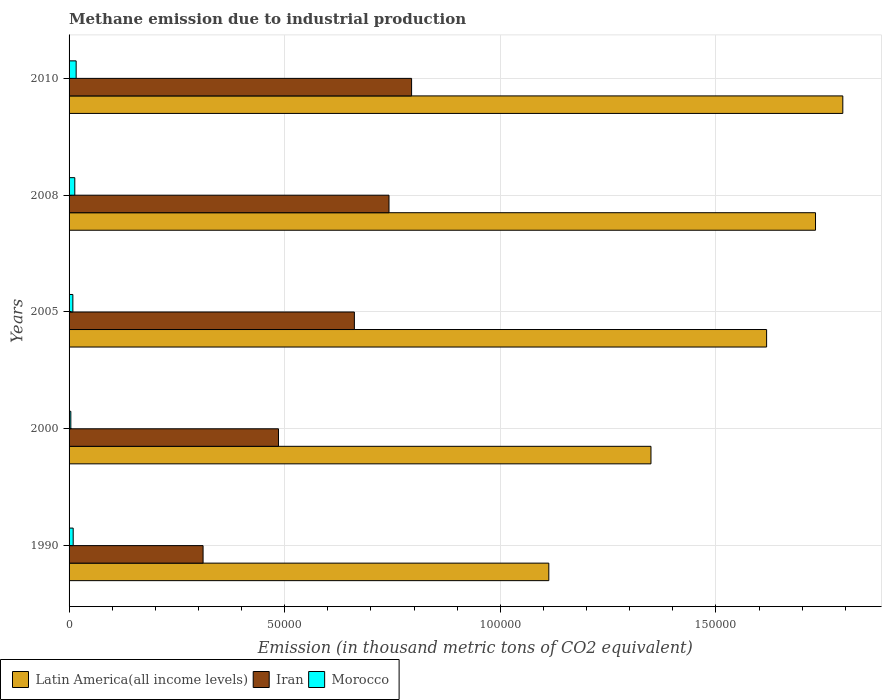How many different coloured bars are there?
Your response must be concise. 3. How many groups of bars are there?
Give a very brief answer. 5. How many bars are there on the 1st tick from the bottom?
Keep it short and to the point. 3. What is the label of the 5th group of bars from the top?
Your response must be concise. 1990. What is the amount of methane emitted in Latin America(all income levels) in 2000?
Make the answer very short. 1.35e+05. Across all years, what is the maximum amount of methane emitted in Latin America(all income levels)?
Your answer should be very brief. 1.79e+05. Across all years, what is the minimum amount of methane emitted in Iran?
Your response must be concise. 3.11e+04. In which year was the amount of methane emitted in Morocco minimum?
Give a very brief answer. 2000. What is the total amount of methane emitted in Latin America(all income levels) in the graph?
Your response must be concise. 7.60e+05. What is the difference between the amount of methane emitted in Iran in 2005 and that in 2008?
Provide a short and direct response. -8028.1. What is the difference between the amount of methane emitted in Morocco in 2005 and the amount of methane emitted in Latin America(all income levels) in 2008?
Make the answer very short. -1.72e+05. What is the average amount of methane emitted in Iran per year?
Ensure brevity in your answer.  5.99e+04. In the year 2010, what is the difference between the amount of methane emitted in Latin America(all income levels) and amount of methane emitted in Morocco?
Your answer should be compact. 1.78e+05. In how many years, is the amount of methane emitted in Latin America(all income levels) greater than 100000 thousand metric tons?
Keep it short and to the point. 5. What is the ratio of the amount of methane emitted in Morocco in 2000 to that in 2008?
Offer a very short reply. 0.31. Is the difference between the amount of methane emitted in Latin America(all income levels) in 2000 and 2008 greater than the difference between the amount of methane emitted in Morocco in 2000 and 2008?
Your response must be concise. No. What is the difference between the highest and the second highest amount of methane emitted in Morocco?
Your answer should be very brief. 313.2. What is the difference between the highest and the lowest amount of methane emitted in Iran?
Provide a succinct answer. 4.84e+04. Is the sum of the amount of methane emitted in Iran in 2000 and 2010 greater than the maximum amount of methane emitted in Morocco across all years?
Your response must be concise. Yes. What does the 2nd bar from the top in 2000 represents?
Provide a succinct answer. Iran. What does the 1st bar from the bottom in 2000 represents?
Keep it short and to the point. Latin America(all income levels). How many bars are there?
Ensure brevity in your answer.  15. How many years are there in the graph?
Your answer should be very brief. 5. Are the values on the major ticks of X-axis written in scientific E-notation?
Make the answer very short. No. Does the graph contain grids?
Your answer should be very brief. Yes. How are the legend labels stacked?
Offer a very short reply. Horizontal. What is the title of the graph?
Give a very brief answer. Methane emission due to industrial production. Does "Guinea-Bissau" appear as one of the legend labels in the graph?
Ensure brevity in your answer.  No. What is the label or title of the X-axis?
Your response must be concise. Emission (in thousand metric tons of CO2 equivalent). What is the Emission (in thousand metric tons of CO2 equivalent) in Latin America(all income levels) in 1990?
Make the answer very short. 1.11e+05. What is the Emission (in thousand metric tons of CO2 equivalent) in Iran in 1990?
Make the answer very short. 3.11e+04. What is the Emission (in thousand metric tons of CO2 equivalent) of Morocco in 1990?
Keep it short and to the point. 955.4. What is the Emission (in thousand metric tons of CO2 equivalent) in Latin America(all income levels) in 2000?
Provide a short and direct response. 1.35e+05. What is the Emission (in thousand metric tons of CO2 equivalent) of Iran in 2000?
Offer a terse response. 4.86e+04. What is the Emission (in thousand metric tons of CO2 equivalent) of Morocco in 2000?
Your answer should be compact. 407.6. What is the Emission (in thousand metric tons of CO2 equivalent) in Latin America(all income levels) in 2005?
Keep it short and to the point. 1.62e+05. What is the Emission (in thousand metric tons of CO2 equivalent) of Iran in 2005?
Your answer should be very brief. 6.62e+04. What is the Emission (in thousand metric tons of CO2 equivalent) of Morocco in 2005?
Your answer should be compact. 877.7. What is the Emission (in thousand metric tons of CO2 equivalent) in Latin America(all income levels) in 2008?
Provide a short and direct response. 1.73e+05. What is the Emission (in thousand metric tons of CO2 equivalent) of Iran in 2008?
Provide a succinct answer. 7.42e+04. What is the Emission (in thousand metric tons of CO2 equivalent) in Morocco in 2008?
Offer a very short reply. 1328.7. What is the Emission (in thousand metric tons of CO2 equivalent) of Latin America(all income levels) in 2010?
Offer a very short reply. 1.79e+05. What is the Emission (in thousand metric tons of CO2 equivalent) of Iran in 2010?
Your response must be concise. 7.94e+04. What is the Emission (in thousand metric tons of CO2 equivalent) in Morocco in 2010?
Offer a terse response. 1641.9. Across all years, what is the maximum Emission (in thousand metric tons of CO2 equivalent) of Latin America(all income levels)?
Offer a terse response. 1.79e+05. Across all years, what is the maximum Emission (in thousand metric tons of CO2 equivalent) of Iran?
Your answer should be very brief. 7.94e+04. Across all years, what is the maximum Emission (in thousand metric tons of CO2 equivalent) of Morocco?
Make the answer very short. 1641.9. Across all years, what is the minimum Emission (in thousand metric tons of CO2 equivalent) of Latin America(all income levels)?
Provide a short and direct response. 1.11e+05. Across all years, what is the minimum Emission (in thousand metric tons of CO2 equivalent) of Iran?
Keep it short and to the point. 3.11e+04. Across all years, what is the minimum Emission (in thousand metric tons of CO2 equivalent) of Morocco?
Your response must be concise. 407.6. What is the total Emission (in thousand metric tons of CO2 equivalent) in Latin America(all income levels) in the graph?
Ensure brevity in your answer.  7.60e+05. What is the total Emission (in thousand metric tons of CO2 equivalent) of Iran in the graph?
Your answer should be compact. 2.99e+05. What is the total Emission (in thousand metric tons of CO2 equivalent) in Morocco in the graph?
Offer a terse response. 5211.3. What is the difference between the Emission (in thousand metric tons of CO2 equivalent) in Latin America(all income levels) in 1990 and that in 2000?
Your response must be concise. -2.37e+04. What is the difference between the Emission (in thousand metric tons of CO2 equivalent) of Iran in 1990 and that in 2000?
Your response must be concise. -1.75e+04. What is the difference between the Emission (in thousand metric tons of CO2 equivalent) of Morocco in 1990 and that in 2000?
Provide a succinct answer. 547.8. What is the difference between the Emission (in thousand metric tons of CO2 equivalent) in Latin America(all income levels) in 1990 and that in 2005?
Your response must be concise. -5.05e+04. What is the difference between the Emission (in thousand metric tons of CO2 equivalent) in Iran in 1990 and that in 2005?
Offer a very short reply. -3.51e+04. What is the difference between the Emission (in thousand metric tons of CO2 equivalent) in Morocco in 1990 and that in 2005?
Offer a very short reply. 77.7. What is the difference between the Emission (in thousand metric tons of CO2 equivalent) of Latin America(all income levels) in 1990 and that in 2008?
Keep it short and to the point. -6.18e+04. What is the difference between the Emission (in thousand metric tons of CO2 equivalent) of Iran in 1990 and that in 2008?
Provide a succinct answer. -4.31e+04. What is the difference between the Emission (in thousand metric tons of CO2 equivalent) of Morocco in 1990 and that in 2008?
Give a very brief answer. -373.3. What is the difference between the Emission (in thousand metric tons of CO2 equivalent) of Latin America(all income levels) in 1990 and that in 2010?
Make the answer very short. -6.82e+04. What is the difference between the Emission (in thousand metric tons of CO2 equivalent) of Iran in 1990 and that in 2010?
Keep it short and to the point. -4.84e+04. What is the difference between the Emission (in thousand metric tons of CO2 equivalent) of Morocco in 1990 and that in 2010?
Your answer should be very brief. -686.5. What is the difference between the Emission (in thousand metric tons of CO2 equivalent) of Latin America(all income levels) in 2000 and that in 2005?
Ensure brevity in your answer.  -2.68e+04. What is the difference between the Emission (in thousand metric tons of CO2 equivalent) of Iran in 2000 and that in 2005?
Provide a short and direct response. -1.76e+04. What is the difference between the Emission (in thousand metric tons of CO2 equivalent) in Morocco in 2000 and that in 2005?
Offer a terse response. -470.1. What is the difference between the Emission (in thousand metric tons of CO2 equivalent) in Latin America(all income levels) in 2000 and that in 2008?
Your answer should be very brief. -3.82e+04. What is the difference between the Emission (in thousand metric tons of CO2 equivalent) in Iran in 2000 and that in 2008?
Make the answer very short. -2.56e+04. What is the difference between the Emission (in thousand metric tons of CO2 equivalent) in Morocco in 2000 and that in 2008?
Your answer should be very brief. -921.1. What is the difference between the Emission (in thousand metric tons of CO2 equivalent) in Latin America(all income levels) in 2000 and that in 2010?
Your response must be concise. -4.45e+04. What is the difference between the Emission (in thousand metric tons of CO2 equivalent) of Iran in 2000 and that in 2010?
Offer a very short reply. -3.09e+04. What is the difference between the Emission (in thousand metric tons of CO2 equivalent) of Morocco in 2000 and that in 2010?
Give a very brief answer. -1234.3. What is the difference between the Emission (in thousand metric tons of CO2 equivalent) in Latin America(all income levels) in 2005 and that in 2008?
Keep it short and to the point. -1.13e+04. What is the difference between the Emission (in thousand metric tons of CO2 equivalent) in Iran in 2005 and that in 2008?
Offer a very short reply. -8028.1. What is the difference between the Emission (in thousand metric tons of CO2 equivalent) in Morocco in 2005 and that in 2008?
Offer a very short reply. -451. What is the difference between the Emission (in thousand metric tons of CO2 equivalent) of Latin America(all income levels) in 2005 and that in 2010?
Keep it short and to the point. -1.77e+04. What is the difference between the Emission (in thousand metric tons of CO2 equivalent) in Iran in 2005 and that in 2010?
Offer a very short reply. -1.33e+04. What is the difference between the Emission (in thousand metric tons of CO2 equivalent) of Morocco in 2005 and that in 2010?
Give a very brief answer. -764.2. What is the difference between the Emission (in thousand metric tons of CO2 equivalent) of Latin America(all income levels) in 2008 and that in 2010?
Provide a succinct answer. -6327. What is the difference between the Emission (in thousand metric tons of CO2 equivalent) in Iran in 2008 and that in 2010?
Your response must be concise. -5239.8. What is the difference between the Emission (in thousand metric tons of CO2 equivalent) of Morocco in 2008 and that in 2010?
Your response must be concise. -313.2. What is the difference between the Emission (in thousand metric tons of CO2 equivalent) in Latin America(all income levels) in 1990 and the Emission (in thousand metric tons of CO2 equivalent) in Iran in 2000?
Offer a terse response. 6.27e+04. What is the difference between the Emission (in thousand metric tons of CO2 equivalent) in Latin America(all income levels) in 1990 and the Emission (in thousand metric tons of CO2 equivalent) in Morocco in 2000?
Give a very brief answer. 1.11e+05. What is the difference between the Emission (in thousand metric tons of CO2 equivalent) of Iran in 1990 and the Emission (in thousand metric tons of CO2 equivalent) of Morocco in 2000?
Make the answer very short. 3.07e+04. What is the difference between the Emission (in thousand metric tons of CO2 equivalent) in Latin America(all income levels) in 1990 and the Emission (in thousand metric tons of CO2 equivalent) in Iran in 2005?
Make the answer very short. 4.51e+04. What is the difference between the Emission (in thousand metric tons of CO2 equivalent) of Latin America(all income levels) in 1990 and the Emission (in thousand metric tons of CO2 equivalent) of Morocco in 2005?
Keep it short and to the point. 1.10e+05. What is the difference between the Emission (in thousand metric tons of CO2 equivalent) of Iran in 1990 and the Emission (in thousand metric tons of CO2 equivalent) of Morocco in 2005?
Your answer should be very brief. 3.02e+04. What is the difference between the Emission (in thousand metric tons of CO2 equivalent) of Latin America(all income levels) in 1990 and the Emission (in thousand metric tons of CO2 equivalent) of Iran in 2008?
Provide a succinct answer. 3.71e+04. What is the difference between the Emission (in thousand metric tons of CO2 equivalent) of Latin America(all income levels) in 1990 and the Emission (in thousand metric tons of CO2 equivalent) of Morocco in 2008?
Provide a succinct answer. 1.10e+05. What is the difference between the Emission (in thousand metric tons of CO2 equivalent) of Iran in 1990 and the Emission (in thousand metric tons of CO2 equivalent) of Morocco in 2008?
Ensure brevity in your answer.  2.97e+04. What is the difference between the Emission (in thousand metric tons of CO2 equivalent) of Latin America(all income levels) in 1990 and the Emission (in thousand metric tons of CO2 equivalent) of Iran in 2010?
Provide a short and direct response. 3.18e+04. What is the difference between the Emission (in thousand metric tons of CO2 equivalent) of Latin America(all income levels) in 1990 and the Emission (in thousand metric tons of CO2 equivalent) of Morocco in 2010?
Ensure brevity in your answer.  1.10e+05. What is the difference between the Emission (in thousand metric tons of CO2 equivalent) in Iran in 1990 and the Emission (in thousand metric tons of CO2 equivalent) in Morocco in 2010?
Your response must be concise. 2.94e+04. What is the difference between the Emission (in thousand metric tons of CO2 equivalent) of Latin America(all income levels) in 2000 and the Emission (in thousand metric tons of CO2 equivalent) of Iran in 2005?
Provide a short and direct response. 6.88e+04. What is the difference between the Emission (in thousand metric tons of CO2 equivalent) of Latin America(all income levels) in 2000 and the Emission (in thousand metric tons of CO2 equivalent) of Morocco in 2005?
Ensure brevity in your answer.  1.34e+05. What is the difference between the Emission (in thousand metric tons of CO2 equivalent) of Iran in 2000 and the Emission (in thousand metric tons of CO2 equivalent) of Morocco in 2005?
Give a very brief answer. 4.77e+04. What is the difference between the Emission (in thousand metric tons of CO2 equivalent) in Latin America(all income levels) in 2000 and the Emission (in thousand metric tons of CO2 equivalent) in Iran in 2008?
Ensure brevity in your answer.  6.07e+04. What is the difference between the Emission (in thousand metric tons of CO2 equivalent) of Latin America(all income levels) in 2000 and the Emission (in thousand metric tons of CO2 equivalent) of Morocco in 2008?
Make the answer very short. 1.34e+05. What is the difference between the Emission (in thousand metric tons of CO2 equivalent) in Iran in 2000 and the Emission (in thousand metric tons of CO2 equivalent) in Morocco in 2008?
Your answer should be compact. 4.72e+04. What is the difference between the Emission (in thousand metric tons of CO2 equivalent) of Latin America(all income levels) in 2000 and the Emission (in thousand metric tons of CO2 equivalent) of Iran in 2010?
Ensure brevity in your answer.  5.55e+04. What is the difference between the Emission (in thousand metric tons of CO2 equivalent) in Latin America(all income levels) in 2000 and the Emission (in thousand metric tons of CO2 equivalent) in Morocco in 2010?
Your answer should be compact. 1.33e+05. What is the difference between the Emission (in thousand metric tons of CO2 equivalent) in Iran in 2000 and the Emission (in thousand metric tons of CO2 equivalent) in Morocco in 2010?
Ensure brevity in your answer.  4.69e+04. What is the difference between the Emission (in thousand metric tons of CO2 equivalent) of Latin America(all income levels) in 2005 and the Emission (in thousand metric tons of CO2 equivalent) of Iran in 2008?
Provide a succinct answer. 8.76e+04. What is the difference between the Emission (in thousand metric tons of CO2 equivalent) of Latin America(all income levels) in 2005 and the Emission (in thousand metric tons of CO2 equivalent) of Morocco in 2008?
Make the answer very short. 1.60e+05. What is the difference between the Emission (in thousand metric tons of CO2 equivalent) of Iran in 2005 and the Emission (in thousand metric tons of CO2 equivalent) of Morocco in 2008?
Make the answer very short. 6.48e+04. What is the difference between the Emission (in thousand metric tons of CO2 equivalent) in Latin America(all income levels) in 2005 and the Emission (in thousand metric tons of CO2 equivalent) in Iran in 2010?
Keep it short and to the point. 8.23e+04. What is the difference between the Emission (in thousand metric tons of CO2 equivalent) of Latin America(all income levels) in 2005 and the Emission (in thousand metric tons of CO2 equivalent) of Morocco in 2010?
Give a very brief answer. 1.60e+05. What is the difference between the Emission (in thousand metric tons of CO2 equivalent) in Iran in 2005 and the Emission (in thousand metric tons of CO2 equivalent) in Morocco in 2010?
Give a very brief answer. 6.45e+04. What is the difference between the Emission (in thousand metric tons of CO2 equivalent) of Latin America(all income levels) in 2008 and the Emission (in thousand metric tons of CO2 equivalent) of Iran in 2010?
Give a very brief answer. 9.37e+04. What is the difference between the Emission (in thousand metric tons of CO2 equivalent) in Latin America(all income levels) in 2008 and the Emission (in thousand metric tons of CO2 equivalent) in Morocco in 2010?
Your answer should be compact. 1.71e+05. What is the difference between the Emission (in thousand metric tons of CO2 equivalent) in Iran in 2008 and the Emission (in thousand metric tons of CO2 equivalent) in Morocco in 2010?
Ensure brevity in your answer.  7.25e+04. What is the average Emission (in thousand metric tons of CO2 equivalent) in Latin America(all income levels) per year?
Ensure brevity in your answer.  1.52e+05. What is the average Emission (in thousand metric tons of CO2 equivalent) in Iran per year?
Keep it short and to the point. 5.99e+04. What is the average Emission (in thousand metric tons of CO2 equivalent) of Morocco per year?
Your response must be concise. 1042.26. In the year 1990, what is the difference between the Emission (in thousand metric tons of CO2 equivalent) of Latin America(all income levels) and Emission (in thousand metric tons of CO2 equivalent) of Iran?
Ensure brevity in your answer.  8.02e+04. In the year 1990, what is the difference between the Emission (in thousand metric tons of CO2 equivalent) in Latin America(all income levels) and Emission (in thousand metric tons of CO2 equivalent) in Morocco?
Keep it short and to the point. 1.10e+05. In the year 1990, what is the difference between the Emission (in thousand metric tons of CO2 equivalent) in Iran and Emission (in thousand metric tons of CO2 equivalent) in Morocco?
Ensure brevity in your answer.  3.01e+04. In the year 2000, what is the difference between the Emission (in thousand metric tons of CO2 equivalent) in Latin America(all income levels) and Emission (in thousand metric tons of CO2 equivalent) in Iran?
Your response must be concise. 8.64e+04. In the year 2000, what is the difference between the Emission (in thousand metric tons of CO2 equivalent) in Latin America(all income levels) and Emission (in thousand metric tons of CO2 equivalent) in Morocco?
Give a very brief answer. 1.35e+05. In the year 2000, what is the difference between the Emission (in thousand metric tons of CO2 equivalent) of Iran and Emission (in thousand metric tons of CO2 equivalent) of Morocco?
Your response must be concise. 4.82e+04. In the year 2005, what is the difference between the Emission (in thousand metric tons of CO2 equivalent) in Latin America(all income levels) and Emission (in thousand metric tons of CO2 equivalent) in Iran?
Your answer should be compact. 9.56e+04. In the year 2005, what is the difference between the Emission (in thousand metric tons of CO2 equivalent) of Latin America(all income levels) and Emission (in thousand metric tons of CO2 equivalent) of Morocco?
Offer a terse response. 1.61e+05. In the year 2005, what is the difference between the Emission (in thousand metric tons of CO2 equivalent) in Iran and Emission (in thousand metric tons of CO2 equivalent) in Morocco?
Provide a short and direct response. 6.53e+04. In the year 2008, what is the difference between the Emission (in thousand metric tons of CO2 equivalent) in Latin America(all income levels) and Emission (in thousand metric tons of CO2 equivalent) in Iran?
Ensure brevity in your answer.  9.89e+04. In the year 2008, what is the difference between the Emission (in thousand metric tons of CO2 equivalent) in Latin America(all income levels) and Emission (in thousand metric tons of CO2 equivalent) in Morocco?
Your answer should be compact. 1.72e+05. In the year 2008, what is the difference between the Emission (in thousand metric tons of CO2 equivalent) of Iran and Emission (in thousand metric tons of CO2 equivalent) of Morocco?
Provide a succinct answer. 7.29e+04. In the year 2010, what is the difference between the Emission (in thousand metric tons of CO2 equivalent) of Latin America(all income levels) and Emission (in thousand metric tons of CO2 equivalent) of Iran?
Provide a short and direct response. 1.00e+05. In the year 2010, what is the difference between the Emission (in thousand metric tons of CO2 equivalent) of Latin America(all income levels) and Emission (in thousand metric tons of CO2 equivalent) of Morocco?
Keep it short and to the point. 1.78e+05. In the year 2010, what is the difference between the Emission (in thousand metric tons of CO2 equivalent) in Iran and Emission (in thousand metric tons of CO2 equivalent) in Morocco?
Provide a short and direct response. 7.78e+04. What is the ratio of the Emission (in thousand metric tons of CO2 equivalent) in Latin America(all income levels) in 1990 to that in 2000?
Provide a succinct answer. 0.82. What is the ratio of the Emission (in thousand metric tons of CO2 equivalent) of Iran in 1990 to that in 2000?
Make the answer very short. 0.64. What is the ratio of the Emission (in thousand metric tons of CO2 equivalent) of Morocco in 1990 to that in 2000?
Offer a terse response. 2.34. What is the ratio of the Emission (in thousand metric tons of CO2 equivalent) in Latin America(all income levels) in 1990 to that in 2005?
Offer a very short reply. 0.69. What is the ratio of the Emission (in thousand metric tons of CO2 equivalent) of Iran in 1990 to that in 2005?
Your answer should be compact. 0.47. What is the ratio of the Emission (in thousand metric tons of CO2 equivalent) in Morocco in 1990 to that in 2005?
Give a very brief answer. 1.09. What is the ratio of the Emission (in thousand metric tons of CO2 equivalent) in Latin America(all income levels) in 1990 to that in 2008?
Your answer should be very brief. 0.64. What is the ratio of the Emission (in thousand metric tons of CO2 equivalent) of Iran in 1990 to that in 2008?
Your answer should be very brief. 0.42. What is the ratio of the Emission (in thousand metric tons of CO2 equivalent) in Morocco in 1990 to that in 2008?
Give a very brief answer. 0.72. What is the ratio of the Emission (in thousand metric tons of CO2 equivalent) of Latin America(all income levels) in 1990 to that in 2010?
Offer a terse response. 0.62. What is the ratio of the Emission (in thousand metric tons of CO2 equivalent) of Iran in 1990 to that in 2010?
Offer a very short reply. 0.39. What is the ratio of the Emission (in thousand metric tons of CO2 equivalent) of Morocco in 1990 to that in 2010?
Provide a short and direct response. 0.58. What is the ratio of the Emission (in thousand metric tons of CO2 equivalent) of Latin America(all income levels) in 2000 to that in 2005?
Make the answer very short. 0.83. What is the ratio of the Emission (in thousand metric tons of CO2 equivalent) in Iran in 2000 to that in 2005?
Your answer should be compact. 0.73. What is the ratio of the Emission (in thousand metric tons of CO2 equivalent) in Morocco in 2000 to that in 2005?
Your response must be concise. 0.46. What is the ratio of the Emission (in thousand metric tons of CO2 equivalent) of Latin America(all income levels) in 2000 to that in 2008?
Your answer should be very brief. 0.78. What is the ratio of the Emission (in thousand metric tons of CO2 equivalent) in Iran in 2000 to that in 2008?
Provide a succinct answer. 0.65. What is the ratio of the Emission (in thousand metric tons of CO2 equivalent) of Morocco in 2000 to that in 2008?
Your answer should be compact. 0.31. What is the ratio of the Emission (in thousand metric tons of CO2 equivalent) of Latin America(all income levels) in 2000 to that in 2010?
Offer a very short reply. 0.75. What is the ratio of the Emission (in thousand metric tons of CO2 equivalent) of Iran in 2000 to that in 2010?
Ensure brevity in your answer.  0.61. What is the ratio of the Emission (in thousand metric tons of CO2 equivalent) in Morocco in 2000 to that in 2010?
Ensure brevity in your answer.  0.25. What is the ratio of the Emission (in thousand metric tons of CO2 equivalent) of Latin America(all income levels) in 2005 to that in 2008?
Keep it short and to the point. 0.93. What is the ratio of the Emission (in thousand metric tons of CO2 equivalent) of Iran in 2005 to that in 2008?
Ensure brevity in your answer.  0.89. What is the ratio of the Emission (in thousand metric tons of CO2 equivalent) in Morocco in 2005 to that in 2008?
Your answer should be very brief. 0.66. What is the ratio of the Emission (in thousand metric tons of CO2 equivalent) in Latin America(all income levels) in 2005 to that in 2010?
Give a very brief answer. 0.9. What is the ratio of the Emission (in thousand metric tons of CO2 equivalent) of Iran in 2005 to that in 2010?
Your response must be concise. 0.83. What is the ratio of the Emission (in thousand metric tons of CO2 equivalent) of Morocco in 2005 to that in 2010?
Offer a terse response. 0.53. What is the ratio of the Emission (in thousand metric tons of CO2 equivalent) in Latin America(all income levels) in 2008 to that in 2010?
Offer a terse response. 0.96. What is the ratio of the Emission (in thousand metric tons of CO2 equivalent) of Iran in 2008 to that in 2010?
Give a very brief answer. 0.93. What is the ratio of the Emission (in thousand metric tons of CO2 equivalent) of Morocco in 2008 to that in 2010?
Offer a terse response. 0.81. What is the difference between the highest and the second highest Emission (in thousand metric tons of CO2 equivalent) of Latin America(all income levels)?
Provide a short and direct response. 6327. What is the difference between the highest and the second highest Emission (in thousand metric tons of CO2 equivalent) of Iran?
Offer a terse response. 5239.8. What is the difference between the highest and the second highest Emission (in thousand metric tons of CO2 equivalent) of Morocco?
Keep it short and to the point. 313.2. What is the difference between the highest and the lowest Emission (in thousand metric tons of CO2 equivalent) of Latin America(all income levels)?
Your answer should be compact. 6.82e+04. What is the difference between the highest and the lowest Emission (in thousand metric tons of CO2 equivalent) in Iran?
Make the answer very short. 4.84e+04. What is the difference between the highest and the lowest Emission (in thousand metric tons of CO2 equivalent) of Morocco?
Ensure brevity in your answer.  1234.3. 